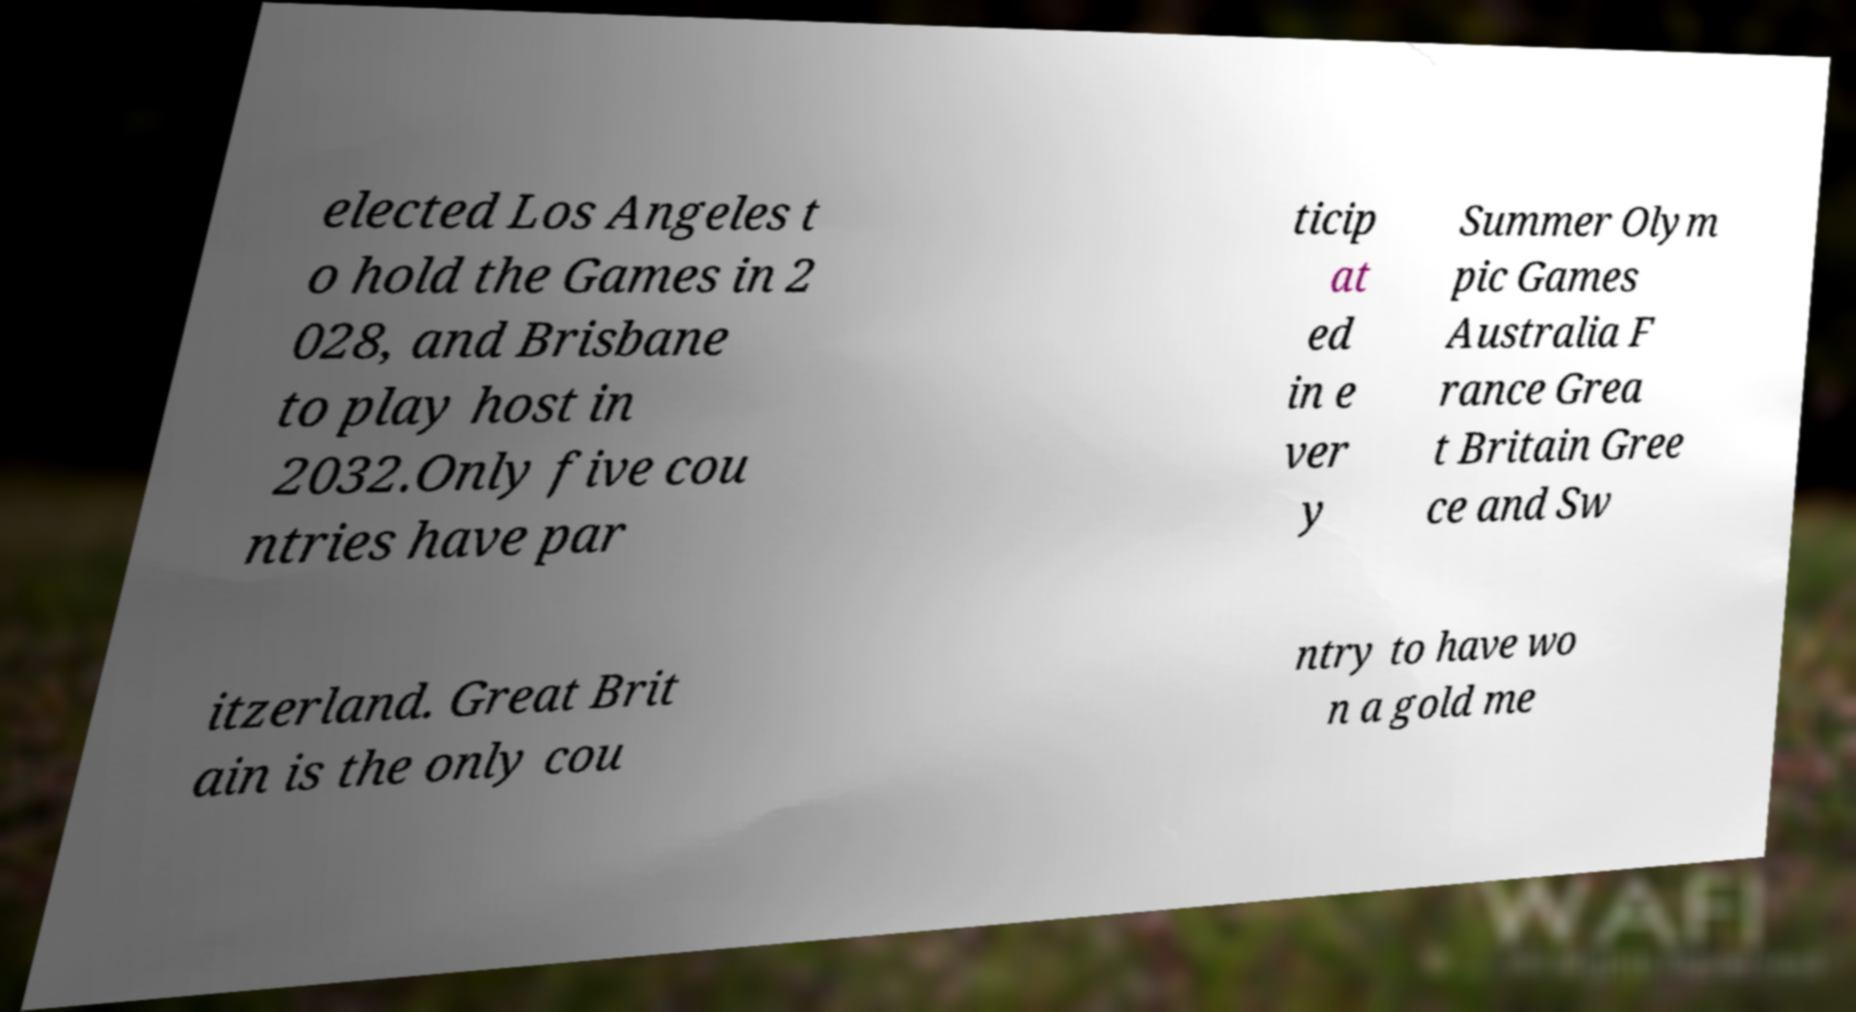What messages or text are displayed in this image? I need them in a readable, typed format. elected Los Angeles t o hold the Games in 2 028, and Brisbane to play host in 2032.Only five cou ntries have par ticip at ed in e ver y Summer Olym pic Games Australia F rance Grea t Britain Gree ce and Sw itzerland. Great Brit ain is the only cou ntry to have wo n a gold me 